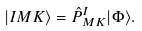Convert formula to latex. <formula><loc_0><loc_0><loc_500><loc_500>| I M K \rangle = \hat { P } ^ { I } _ { M K } | \Phi \rangle .</formula> 